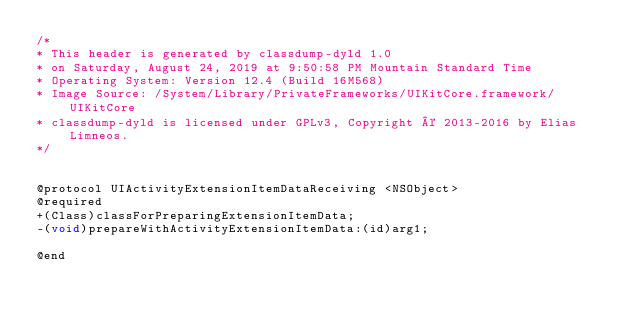Convert code to text. <code><loc_0><loc_0><loc_500><loc_500><_C_>/*
* This header is generated by classdump-dyld 1.0
* on Saturday, August 24, 2019 at 9:50:58 PM Mountain Standard Time
* Operating System: Version 12.4 (Build 16M568)
* Image Source: /System/Library/PrivateFrameworks/UIKitCore.framework/UIKitCore
* classdump-dyld is licensed under GPLv3, Copyright © 2013-2016 by Elias Limneos.
*/


@protocol UIActivityExtensionItemDataReceiving <NSObject>
@required
+(Class)classForPreparingExtensionItemData;
-(void)prepareWithActivityExtensionItemData:(id)arg1;

@end

</code> 